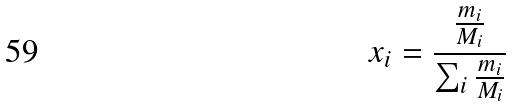Convert formula to latex. <formula><loc_0><loc_0><loc_500><loc_500>x _ { i } = \frac { \frac { m _ { i } } { M _ { i } } } { \sum _ { i } \frac { m _ { i } } { M _ { i } } }</formula> 